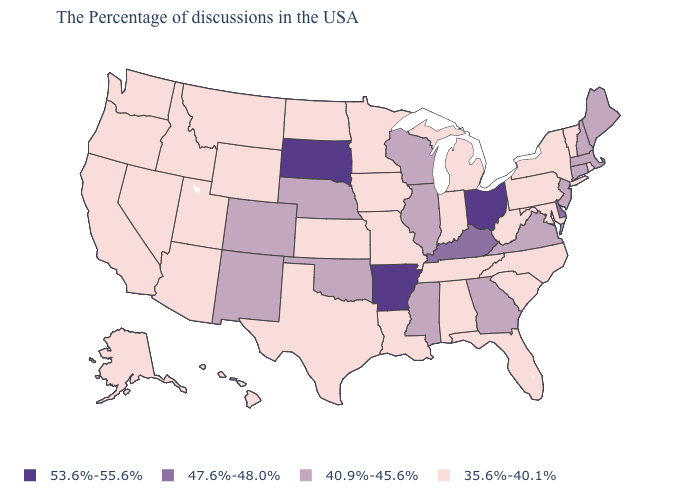Which states hav the highest value in the South?
Give a very brief answer. Arkansas. Does the map have missing data?
Quick response, please. No. What is the value of Oklahoma?
Be succinct. 40.9%-45.6%. What is the value of Arkansas?
Keep it brief. 53.6%-55.6%. What is the value of North Dakota?
Give a very brief answer. 35.6%-40.1%. Does the map have missing data?
Give a very brief answer. No. Does Pennsylvania have a higher value than Idaho?
Answer briefly. No. What is the value of Pennsylvania?
Short answer required. 35.6%-40.1%. Name the states that have a value in the range 47.6%-48.0%?
Keep it brief. Delaware, Kentucky. What is the highest value in the South ?
Keep it brief. 53.6%-55.6%. What is the highest value in states that border New Mexico?
Write a very short answer. 40.9%-45.6%. Does Minnesota have a lower value than Delaware?
Answer briefly. Yes. Which states have the lowest value in the USA?
Quick response, please. Rhode Island, Vermont, New York, Maryland, Pennsylvania, North Carolina, South Carolina, West Virginia, Florida, Michigan, Indiana, Alabama, Tennessee, Louisiana, Missouri, Minnesota, Iowa, Kansas, Texas, North Dakota, Wyoming, Utah, Montana, Arizona, Idaho, Nevada, California, Washington, Oregon, Alaska, Hawaii. What is the value of Alabama?
Give a very brief answer. 35.6%-40.1%. What is the value of South Carolina?
Write a very short answer. 35.6%-40.1%. 